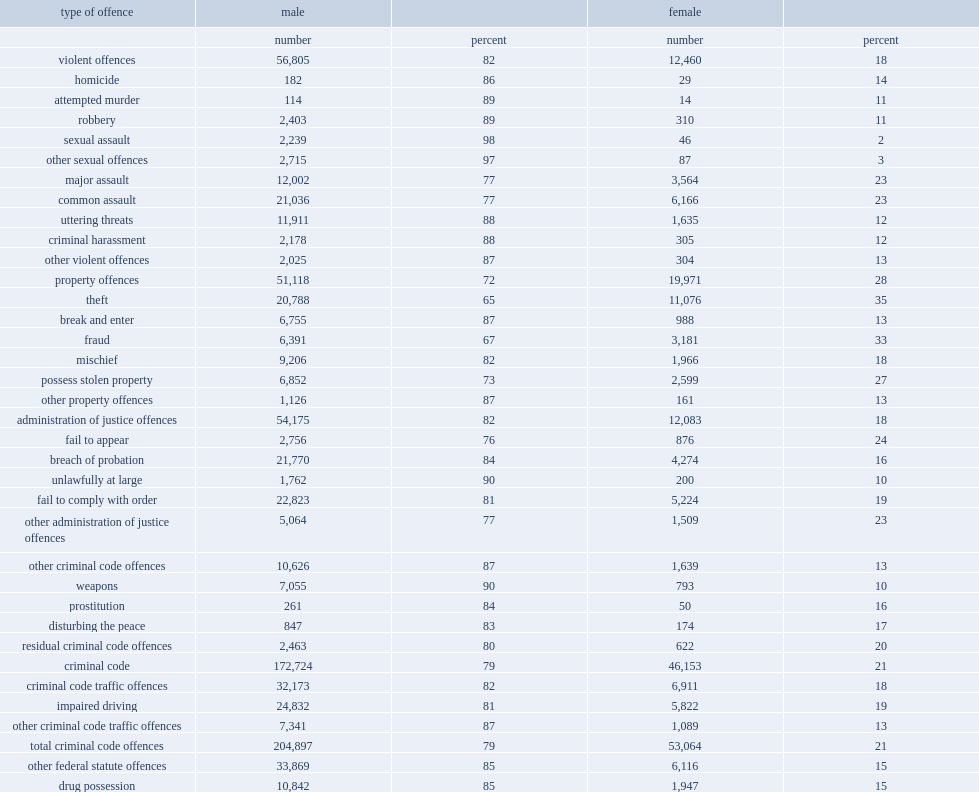Parse the table in full. {'header': ['type of offence', 'male', '', 'female', ''], 'rows': [['', 'number', 'percent', 'number', 'percent'], ['violent offences', '56,805', '82', '12,460', '18'], ['homicide', '182', '86', '29', '14'], ['attempted murder', '114', '89', '14', '11'], ['robbery', '2,403', '89', '310', '11'], ['sexual assault', '2,239', '98', '46', '2'], ['other sexual offences', '2,715', '97', '87', '3'], ['major assault', '12,002', '77', '3,564', '23'], ['common assault', '21,036', '77', '6,166', '23'], ['uttering threats', '11,911', '88', '1,635', '12'], ['criminal harassment', '2,178', '88', '305', '12'], ['other violent offences', '2,025', '87', '304', '13'], ['property offences', '51,118', '72', '19,971', '28'], ['theft', '20,788', '65', '11,076', '35'], ['break and enter', '6,755', '87', '988', '13'], ['fraud', '6,391', '67', '3,181', '33'], ['mischief', '9,206', '82', '1,966', '18'], ['possess stolen property', '6,852', '73', '2,599', '27'], ['other property offences', '1,126', '87', '161', '13'], ['administration of justice offences', '54,175', '82', '12,083', '18'], ['fail to appear', '2,756', '76', '876', '24'], ['breach of probation', '21,770', '84', '4,274', '16'], ['unlawfully at large', '1,762', '90', '200', '10'], ['fail to comply with order', '22,823', '81', '5,224', '19'], ['other administration of justice offences', '5,064', '77', '1,509', '23'], ['other criminal code offences', '10,626', '87', '1,639', '13'], ['weapons', '7,055', '90', '793', '10'], ['prostitution', '261', '84', '50', '16'], ['disturbing the peace', '847', '83', '174', '17'], ['residual criminal code offences', '2,463', '80', '622', '20'], ['criminal code', '172,724', '79', '46,153', '21'], ['criminal code traffic offences', '32,173', '82', '6,911', '18'], ['impaired driving', '24,832', '81', '5,822', '19'], ['other criminal code traffic offences', '7,341', '87', '1,089', '13'], ['total criminal code offences', '204,897', '79', '53,064', '21'], ['other federal statute offences', '33,869', '85', '6,116', '15'], ['drug possession', '10,842', '85', '1,947', '15'], ['other drug offences', '6,456', '79', '1,671', '21'], ['youth criminal justice act', '568', '81', '132', '19'], ['residual federal statute offences', '16,003', '87', '2,366', '13'], ['total offences', '238,766', '80', '59,180', '20']]} How many percentage points were male among accused persons in adult criminal court? 80.0. 